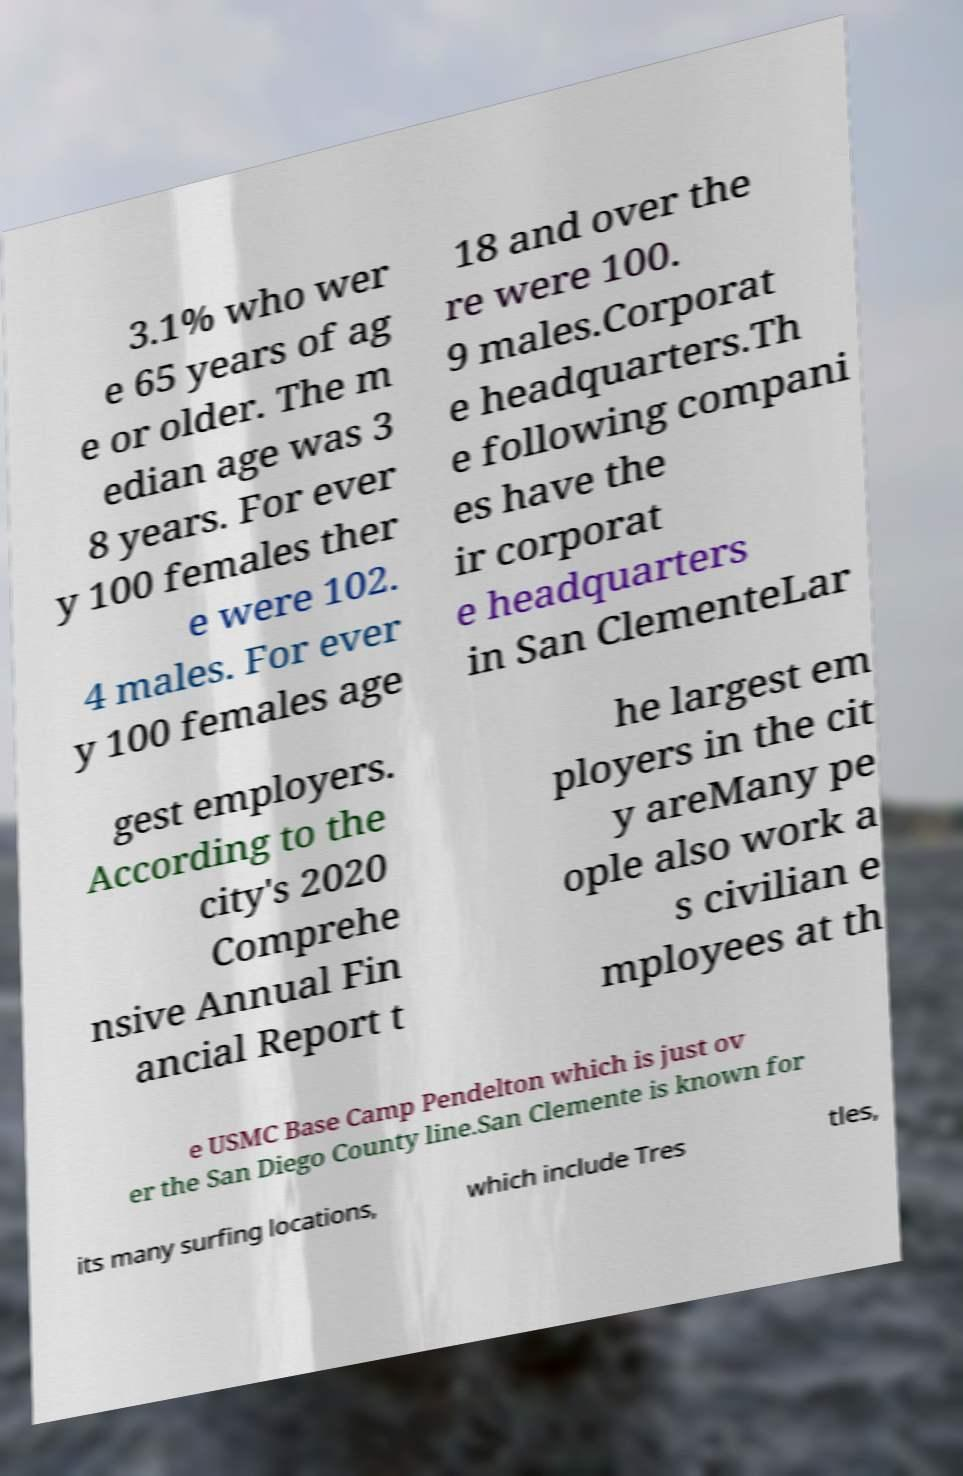There's text embedded in this image that I need extracted. Can you transcribe it verbatim? 3.1% who wer e 65 years of ag e or older. The m edian age was 3 8 years. For ever y 100 females ther e were 102. 4 males. For ever y 100 females age 18 and over the re were 100. 9 males.Corporat e headquarters.Th e following compani es have the ir corporat e headquarters in San ClementeLar gest employers. According to the city's 2020 Comprehe nsive Annual Fin ancial Report t he largest em ployers in the cit y areMany pe ople also work a s civilian e mployees at th e USMC Base Camp Pendelton which is just ov er the San Diego County line.San Clemente is known for its many surfing locations, which include Tres tles, 